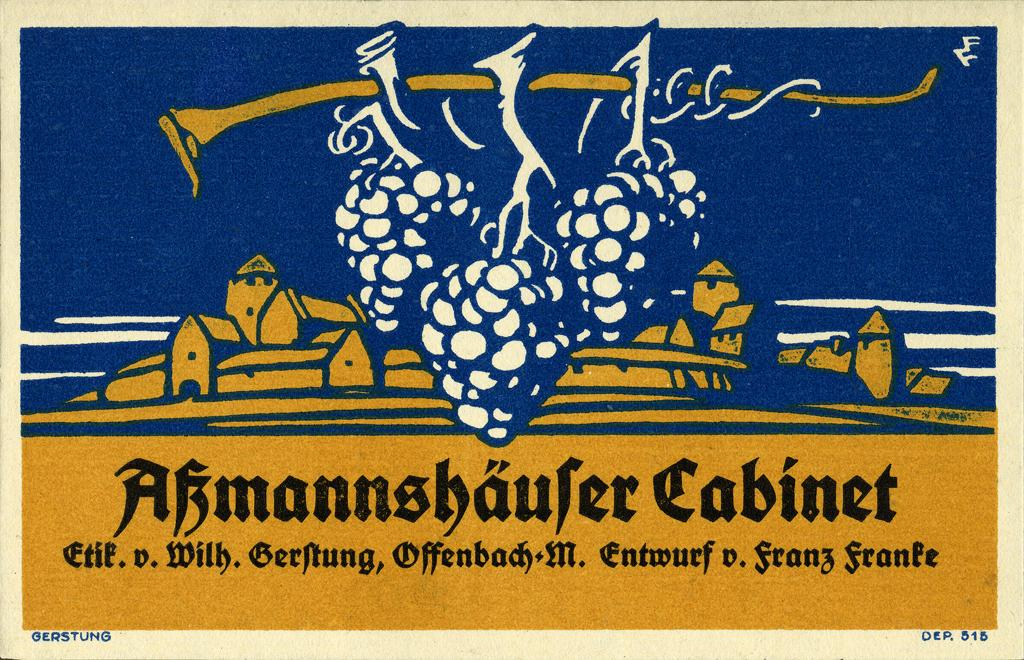Provide a one-sentence caption for the provided image. Three bunches of grapes hanging from a branch in front of a village with the caption "Abmannshaufer Cabinet". 